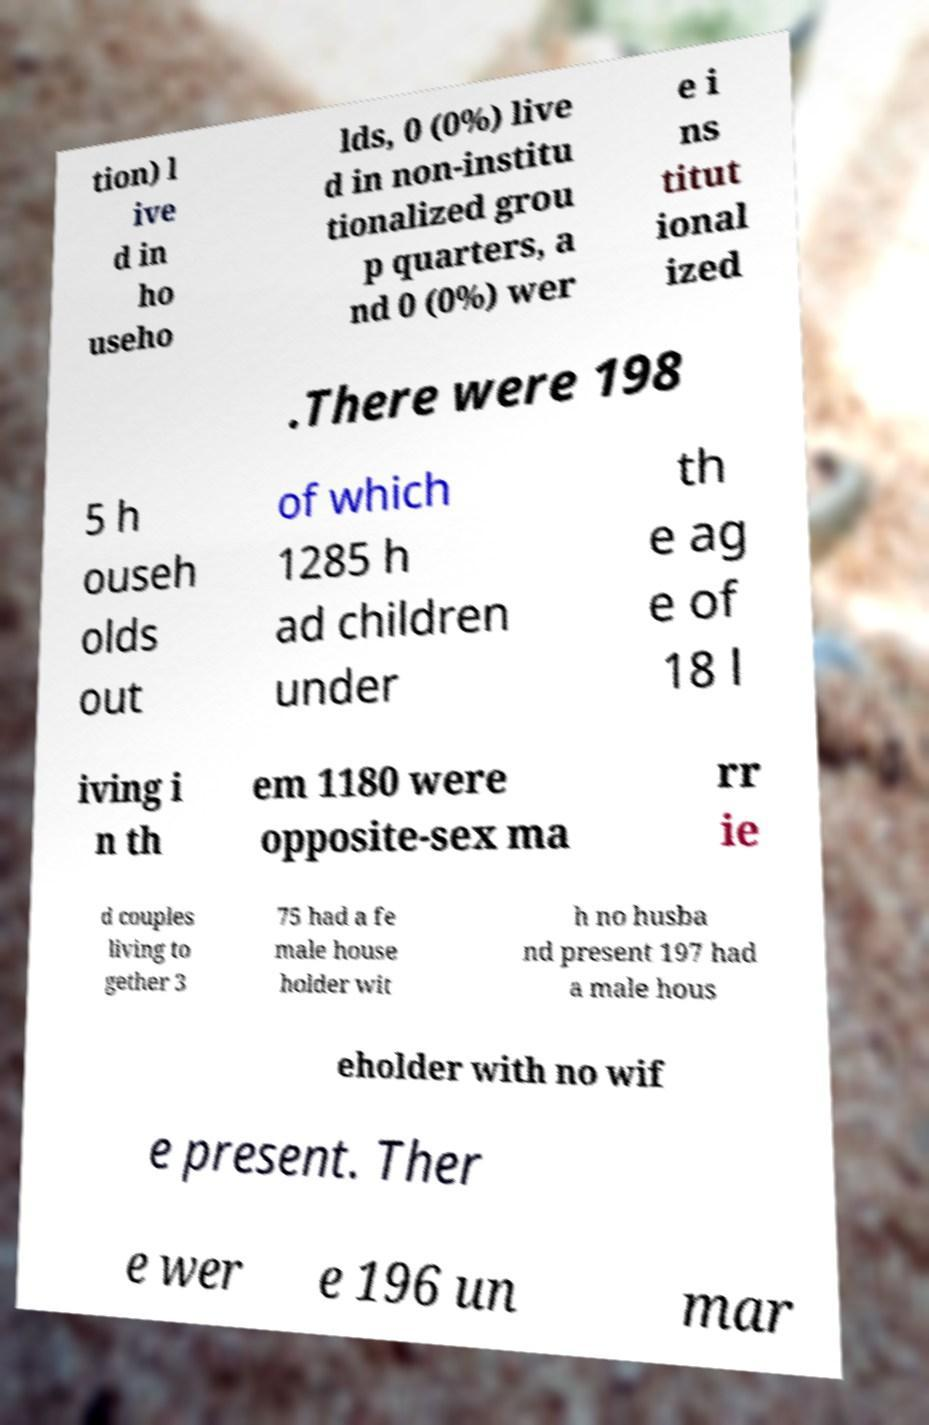Could you extract and type out the text from this image? tion) l ive d in ho useho lds, 0 (0%) live d in non-institu tionalized grou p quarters, a nd 0 (0%) wer e i ns titut ional ized .There were 198 5 h ouseh olds out of which 1285 h ad children under th e ag e of 18 l iving i n th em 1180 were opposite-sex ma rr ie d couples living to gether 3 75 had a fe male house holder wit h no husba nd present 197 had a male hous eholder with no wif e present. Ther e wer e 196 un mar 